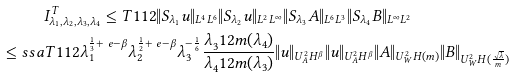Convert formula to latex. <formula><loc_0><loc_0><loc_500><loc_500>& I _ { \lambda _ { 1 } , \lambda _ { 2 } , \lambda _ { 3 } , \lambda _ { 4 } } ^ { T } \leq T ^ { } { 1 } { 1 2 } \| S _ { \lambda _ { 1 } } u \| _ { L ^ { 4 } L ^ { 6 } } \| S _ { \lambda _ { 2 } } u \| _ { L ^ { 2 } L ^ { \infty } } \| S _ { \lambda _ { 3 } } A \| _ { L ^ { 6 } L ^ { 3 } } \| S _ { \lambda _ { 4 } } B \| _ { L ^ { \infty } L ^ { 2 } } \\ \leq s s a & T ^ { } { 1 } { 1 2 } \lambda _ { 1 } ^ { \frac { 1 } { 3 } + \ e - \beta } \lambda _ { 2 } ^ { \frac { 1 } { 2 } + \ e - \beta } \lambda _ { 3 } ^ { - \frac { 1 } { 6 } } \frac { \lambda _ { 3 } ^ { } { 1 } 2 m ( \lambda _ { 4 } ) } { \lambda _ { 4 } ^ { } { 1 } 2 m ( \lambda _ { 3 } ) } \| u \| _ { U ^ { 2 } _ { A } H ^ { \beta } } \| u \| _ { U ^ { 2 } _ { A } H ^ { \beta } } \| A \| _ { U ^ { 2 } _ { W } H ( m ) } \| B \| _ { U ^ { 2 } _ { W } H ( \frac { \sqrt { \lambda } } { m } ) }</formula> 